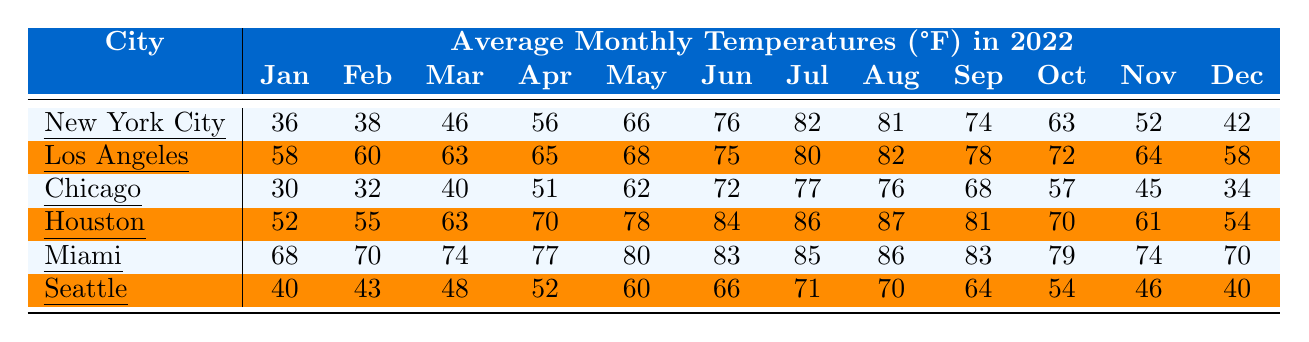What is the average temperature of Chicago in July? In the table, the average temperature of Chicago in July is listed as 77°F.
Answer: 77°F What was the highest average temperature recorded in any city in August? For August, Miami has the highest average temperature at 86°F.
Answer: 86°F Which city had the lowest average temperature in January? In January, Chicago has the lowest average temperature of 30°F compared to other cities.
Answer: Chicago What is the difference in average temperatures between Los Angeles and New York City in February? The average temperature for Los Angeles in February is 60°F and for New York City is 38°F. The difference is 60 - 38 = 22°F.
Answer: 22°F What city had an average temperature above 80°F for both July and August? Houston had average temperatures of 86°F in July and 87°F in August, both above 80°F.
Answer: Houston Which city experienced the lowest average temperature in December? Looking at December temperatures, Chicago recorded the lowest average temperature at 34°F.
Answer: Chicago What is the average temperature for Miami over the entire year? The total average temperatures for each month are: 68 + 70 + 74 + 77 + 80 + 83 + 85 + 86 + 83 + 79 + 74 + 70 = 918. Divide 918 by 12 gives an average of 76.5°F.
Answer: 76.5°F Did Seattle ever exceed an average temperature of 70°F in any month? In Seattle, the highest average temperature is 71°F in July but it does not exceed 70°F in any month.
Answer: No What is the median average temperature for New York City? The monthly temperatures for New York City are: 36, 38, 46, 56, 66, 76, 82, 81, 74, 63, 52, 42. Sorting these gives 36, 38, 42, 46, 52, 56, 63, 66, 74, 76, 81, 82. The median (average of the 6th and 7th) is (56 + 63) / 2 = 59.5°F.
Answer: 59.5°F What were the average temperatures for Houston in the second quarter (April to June)? The average temperatures in Houston from April to June are 70°F (April), 78°F (May), and 84°F (June). Adding these gives 70 + 78 + 84 = 232°F. Dividing this by 3 gives an average of 77.33°F.
Answer: 77.33°F 